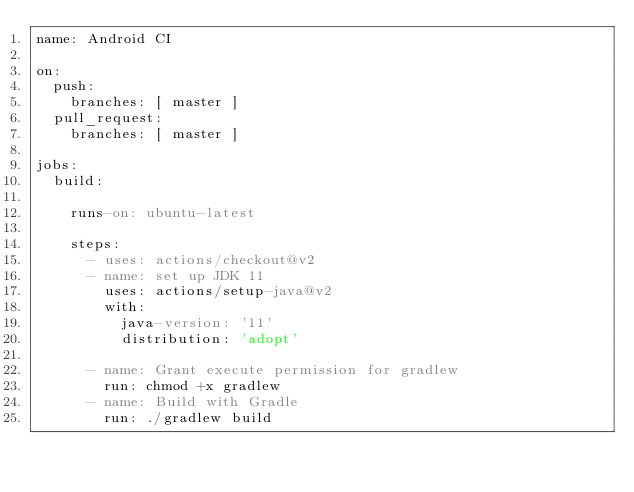<code> <loc_0><loc_0><loc_500><loc_500><_YAML_>name: Android CI

on:
  push:
    branches: [ master ]
  pull_request:
    branches: [ master ]

jobs:
  build:

    runs-on: ubuntu-latest

    steps:
      - uses: actions/checkout@v2
      - name: set up JDK 11
        uses: actions/setup-java@v2
        with:
          java-version: '11'
          distribution: 'adopt'

      - name: Grant execute permission for gradlew
        run: chmod +x gradlew
      - name: Build with Gradle
        run: ./gradlew build
</code> 